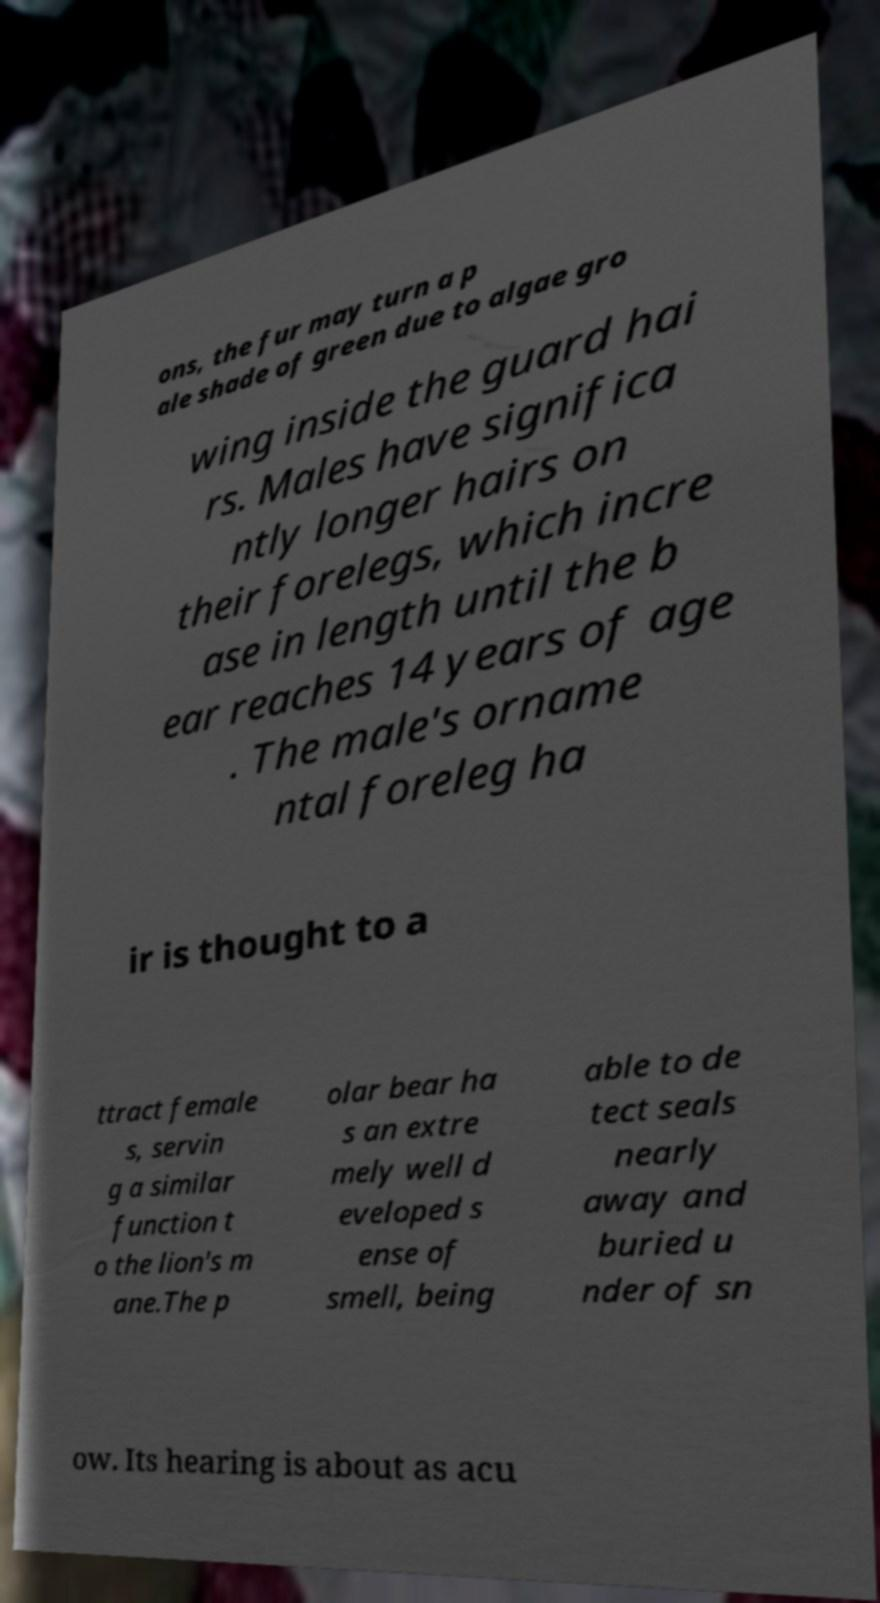Please read and relay the text visible in this image. What does it say? ons, the fur may turn a p ale shade of green due to algae gro wing inside the guard hai rs. Males have significa ntly longer hairs on their forelegs, which incre ase in length until the b ear reaches 14 years of age . The male's orname ntal foreleg ha ir is thought to a ttract female s, servin g a similar function t o the lion's m ane.The p olar bear ha s an extre mely well d eveloped s ense of smell, being able to de tect seals nearly away and buried u nder of sn ow. Its hearing is about as acu 